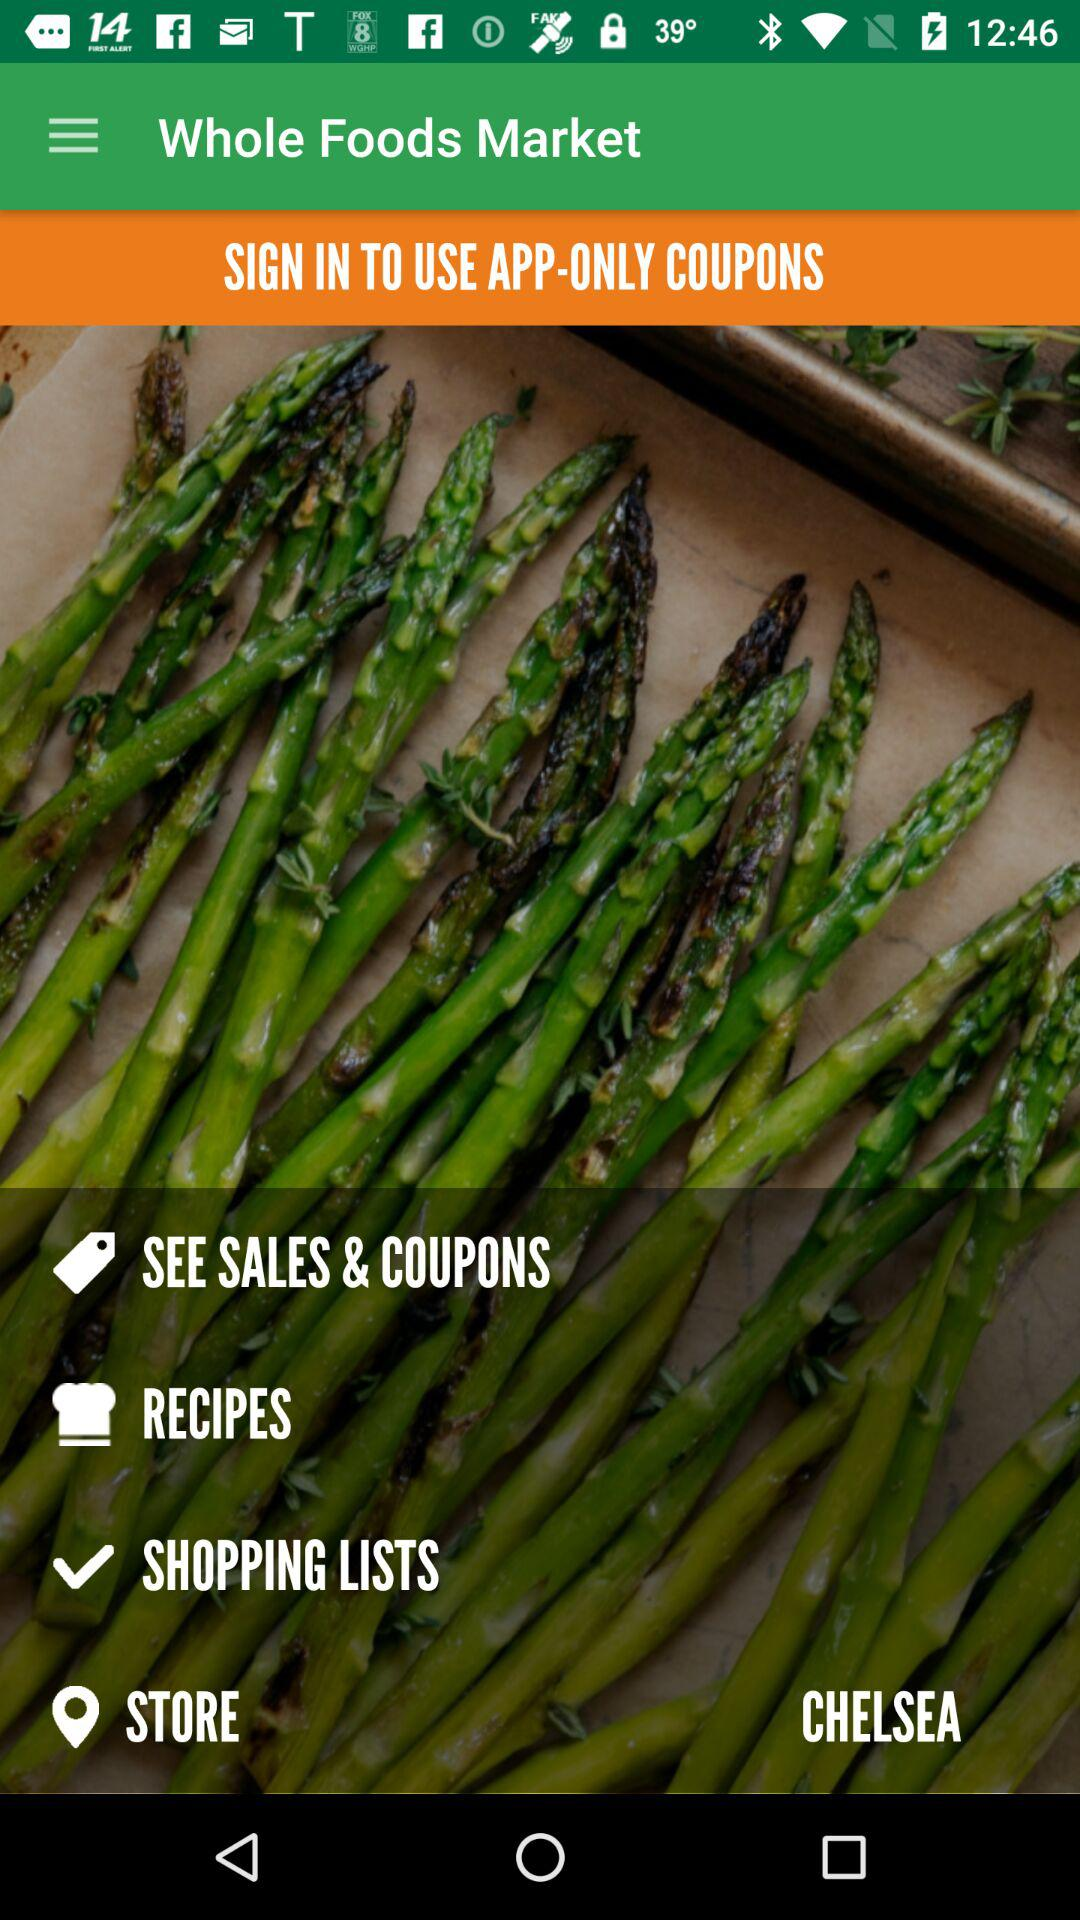Which option is tick marked?
When the provided information is insufficient, respond with <no answer>. <no answer> 